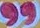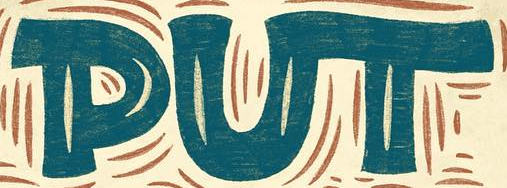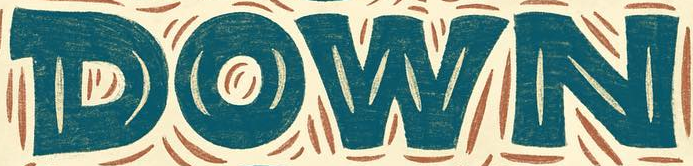Identify the words shown in these images in order, separated by a semicolon. "; PUT; DOWN 